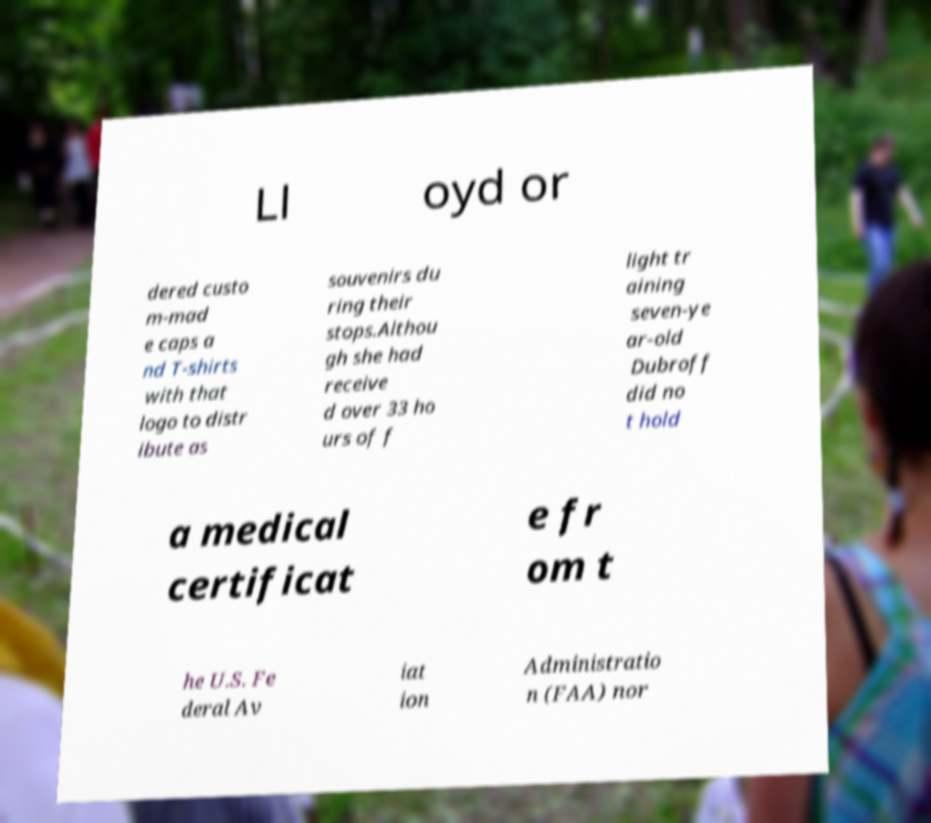There's text embedded in this image that I need extracted. Can you transcribe it verbatim? Ll oyd or dered custo m-mad e caps a nd T-shirts with that logo to distr ibute as souvenirs du ring their stops.Althou gh she had receive d over 33 ho urs of f light tr aining seven-ye ar-old Dubroff did no t hold a medical certificat e fr om t he U.S. Fe deral Av iat ion Administratio n (FAA) nor 